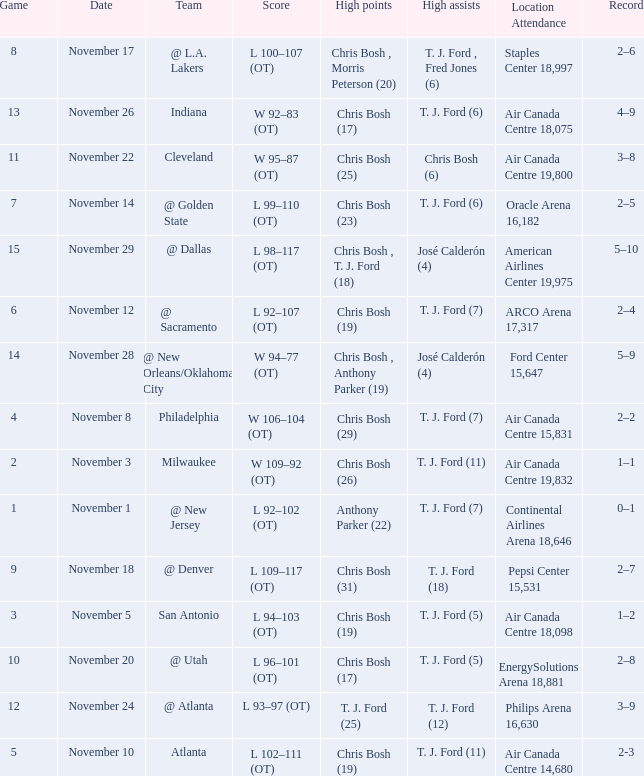What team played on November 28? @ New Orleans/Oklahoma City. 